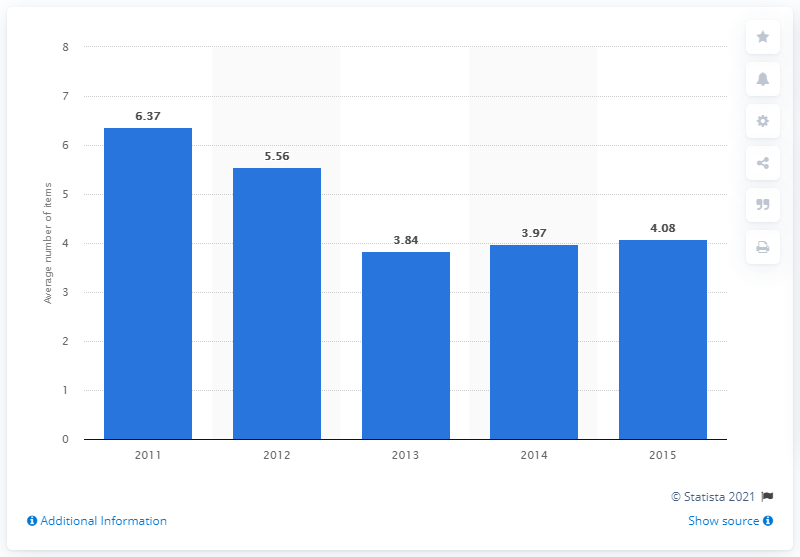Point out several critical features in this image. On average, consumers bought 4.08 items when shopping on Black Friday in 2015. 